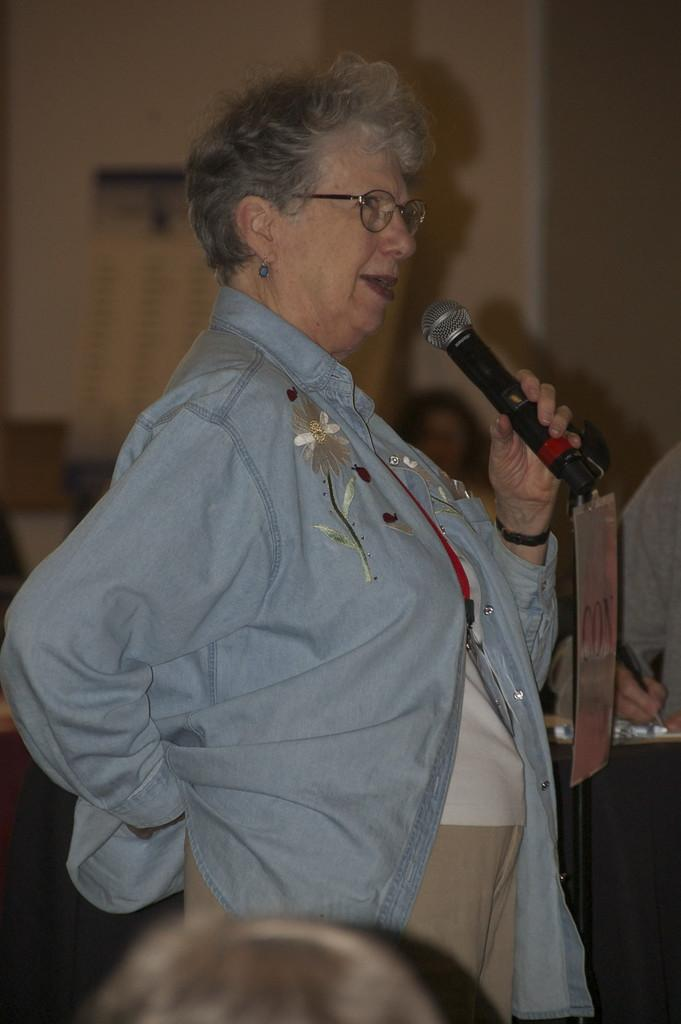What is the woman doing in the image? The woman is standing and talking. What object is the woman holding in the image? The woman is holding a microphone. Can you describe the woman's appearance in the image? The woman is wearing spectacles. Can you see any fog in the image? There is no fog visible in the image. How many hands does the woman have in the image? The woman has two hands in the image, but the number of hands is not relevant to the image. Is the woman's daughter present in the image? There is no information about the woman's daughter in the provided facts, so it cannot be determined from the image. 